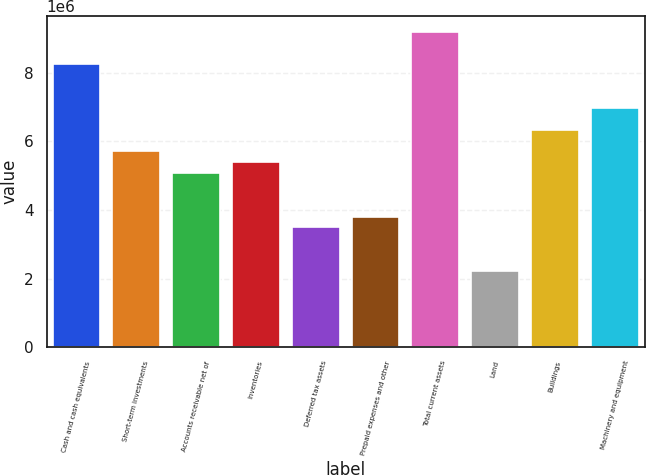Convert chart. <chart><loc_0><loc_0><loc_500><loc_500><bar_chart><fcel>Cash and cash equivalents<fcel>Short-term investments<fcel>Accounts receivable net of<fcel>Inventories<fcel>Deferred tax assets<fcel>Prepaid expenses and other<fcel>Total current assets<fcel>Land<fcel>Buildings<fcel>Machinery and equipment<nl><fcel>8.24574e+06<fcel>5.70964e+06<fcel>5.07562e+06<fcel>5.39263e+06<fcel>3.49056e+06<fcel>3.80757e+06<fcel>9.19678e+06<fcel>2.22251e+06<fcel>6.34367e+06<fcel>6.97769e+06<nl></chart> 